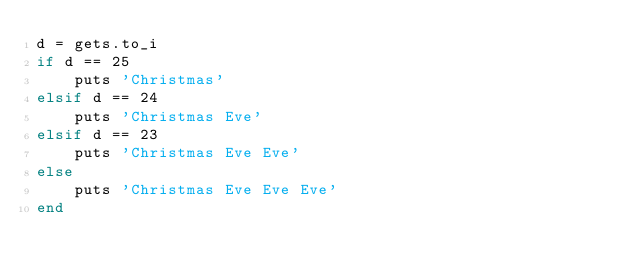<code> <loc_0><loc_0><loc_500><loc_500><_Ruby_>d = gets.to_i
if d == 25
    puts 'Christmas'
elsif d == 24
    puts 'Christmas Eve'
elsif d == 23
    puts 'Christmas Eve Eve'
else
    puts 'Christmas Eve Eve Eve'
end     </code> 